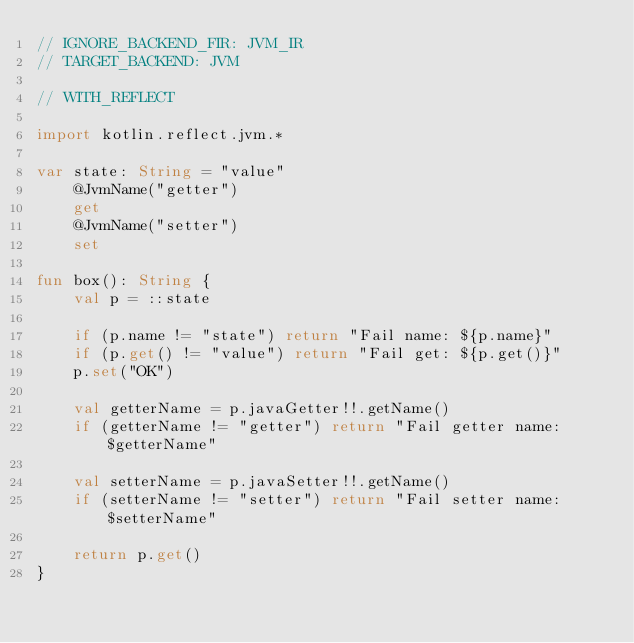Convert code to text. <code><loc_0><loc_0><loc_500><loc_500><_Kotlin_>// IGNORE_BACKEND_FIR: JVM_IR
// TARGET_BACKEND: JVM

// WITH_REFLECT

import kotlin.reflect.jvm.*

var state: String = "value"
    @JvmName("getter")
    get
    @JvmName("setter")
    set

fun box(): String {
    val p = ::state

    if (p.name != "state") return "Fail name: ${p.name}"
    if (p.get() != "value") return "Fail get: ${p.get()}"
    p.set("OK")

    val getterName = p.javaGetter!!.getName()
    if (getterName != "getter") return "Fail getter name: $getterName"

    val setterName = p.javaSetter!!.getName()
    if (setterName != "setter") return "Fail setter name: $setterName"

    return p.get()
}
</code> 